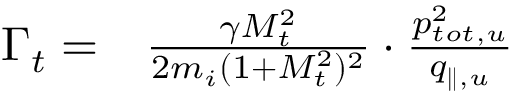Convert formula to latex. <formula><loc_0><loc_0><loc_500><loc_500>\begin{array} { r l } { \Gamma _ { t } = } & \frac { \gamma M _ { t } ^ { 2 } } { 2 m _ { i } ( 1 + M _ { t } ^ { 2 } ) ^ { 2 } } \cdot \frac { p _ { t o t , u } ^ { 2 } } { q _ { \| , u } } } \end{array}</formula> 